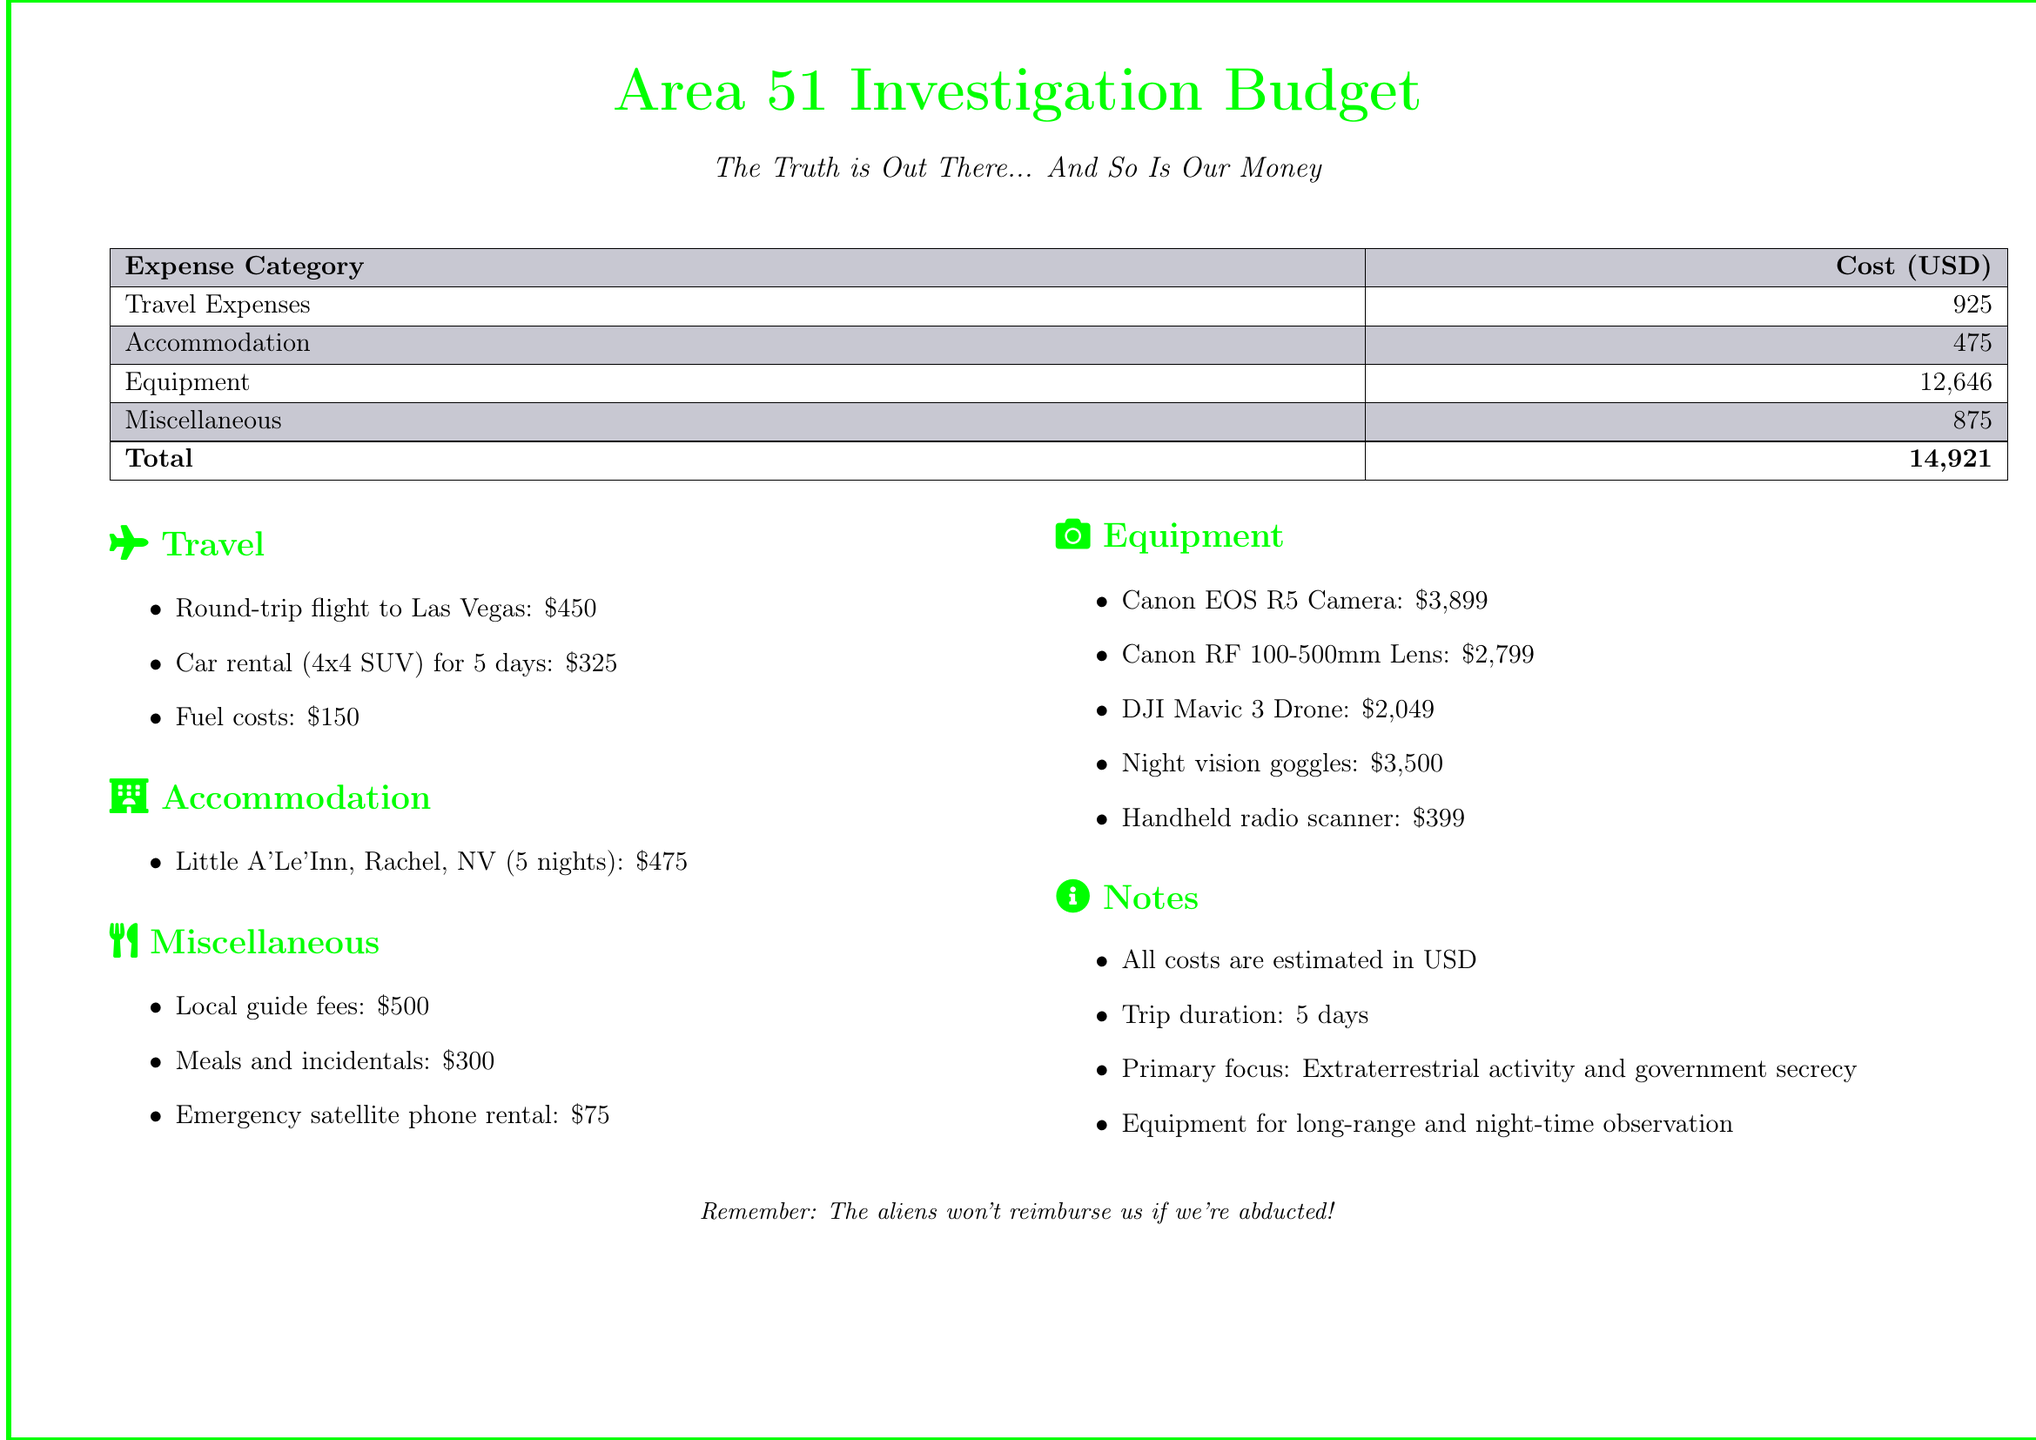What is the total budget for the investigation? The total budget is listed in the document under the total costs, which sum up all expenses.
Answer: 14,921 How much is allocated for equipment? The document specifies the cost allocated for equipment under the equipment section.
Answer: 12,646 What is the cost of accommodation? The accommodation cost is detailed in the accommodation section of the document.
Answer: 475 How many nights will they stay at Little A'Le'Inn? The duration of stay at Little A'Le'Inn is mentioned in the accommodation section.
Answer: 5 nights What specific type of vehicle is rented for the trip? The document indicates the specific vehicle type rented under the travel section.
Answer: 4x4 SUV How much is the cost for meals and incidentals? The cost for meals and incidentals is mentioned in the miscellaneous section.
Answer: 300 What is the cost of the Canon EOS R5 camera? The cost of the Canon EOS R5 camera is specified in the equipment section of the document.
Answer: 3,899 What is the primary focus of the trip? The primary focus of the trip is indicated in the notes section of the document.
Answer: Extraterrestrial activity and government secrecy How much are local guide fees? Local guide fees are listed in the miscellaneous section of the document.
Answer: 500 What type of drone is purchased for the investigation? The type of drone is identified in the equipment section of the document.
Answer: DJI Mavic 3 Drone 